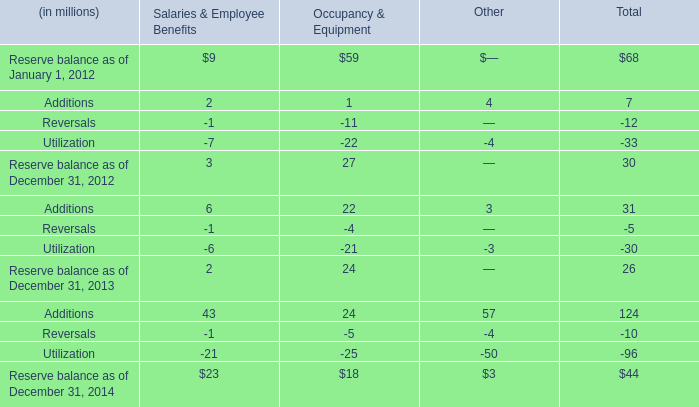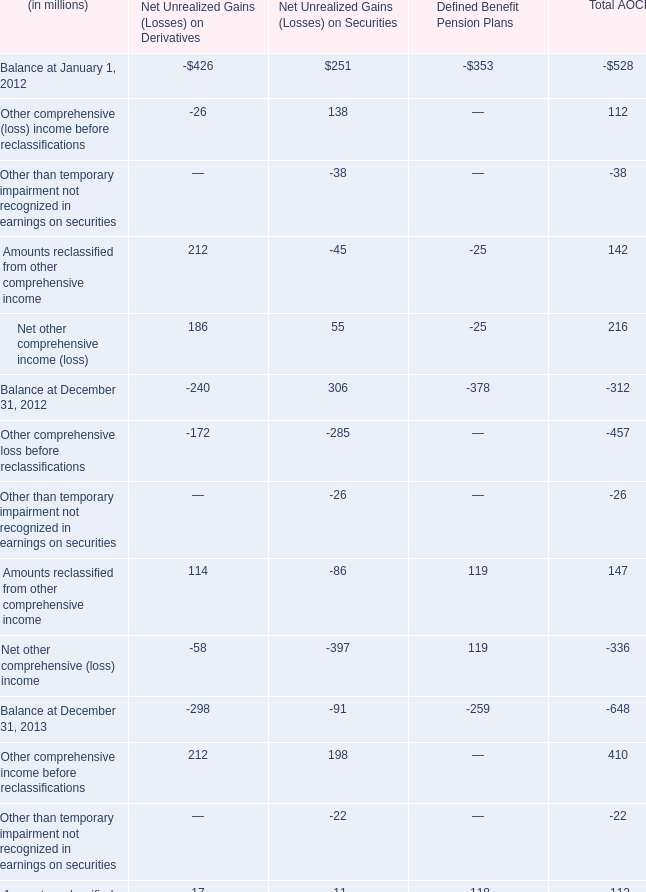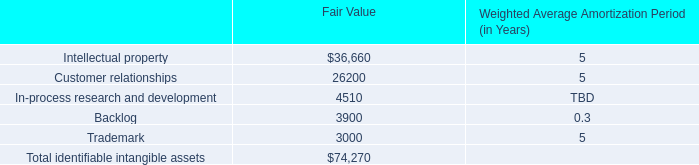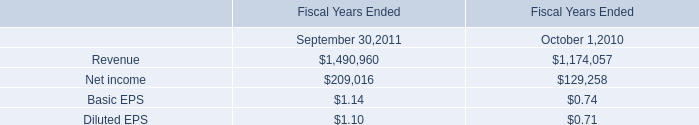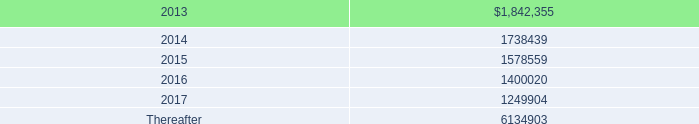for 2012 and 2011 , percentage rentals based on tenants 2019 sales totaled what in thousands? 
Computations: (8466000 + 7995000)
Answer: 16461000.0. 